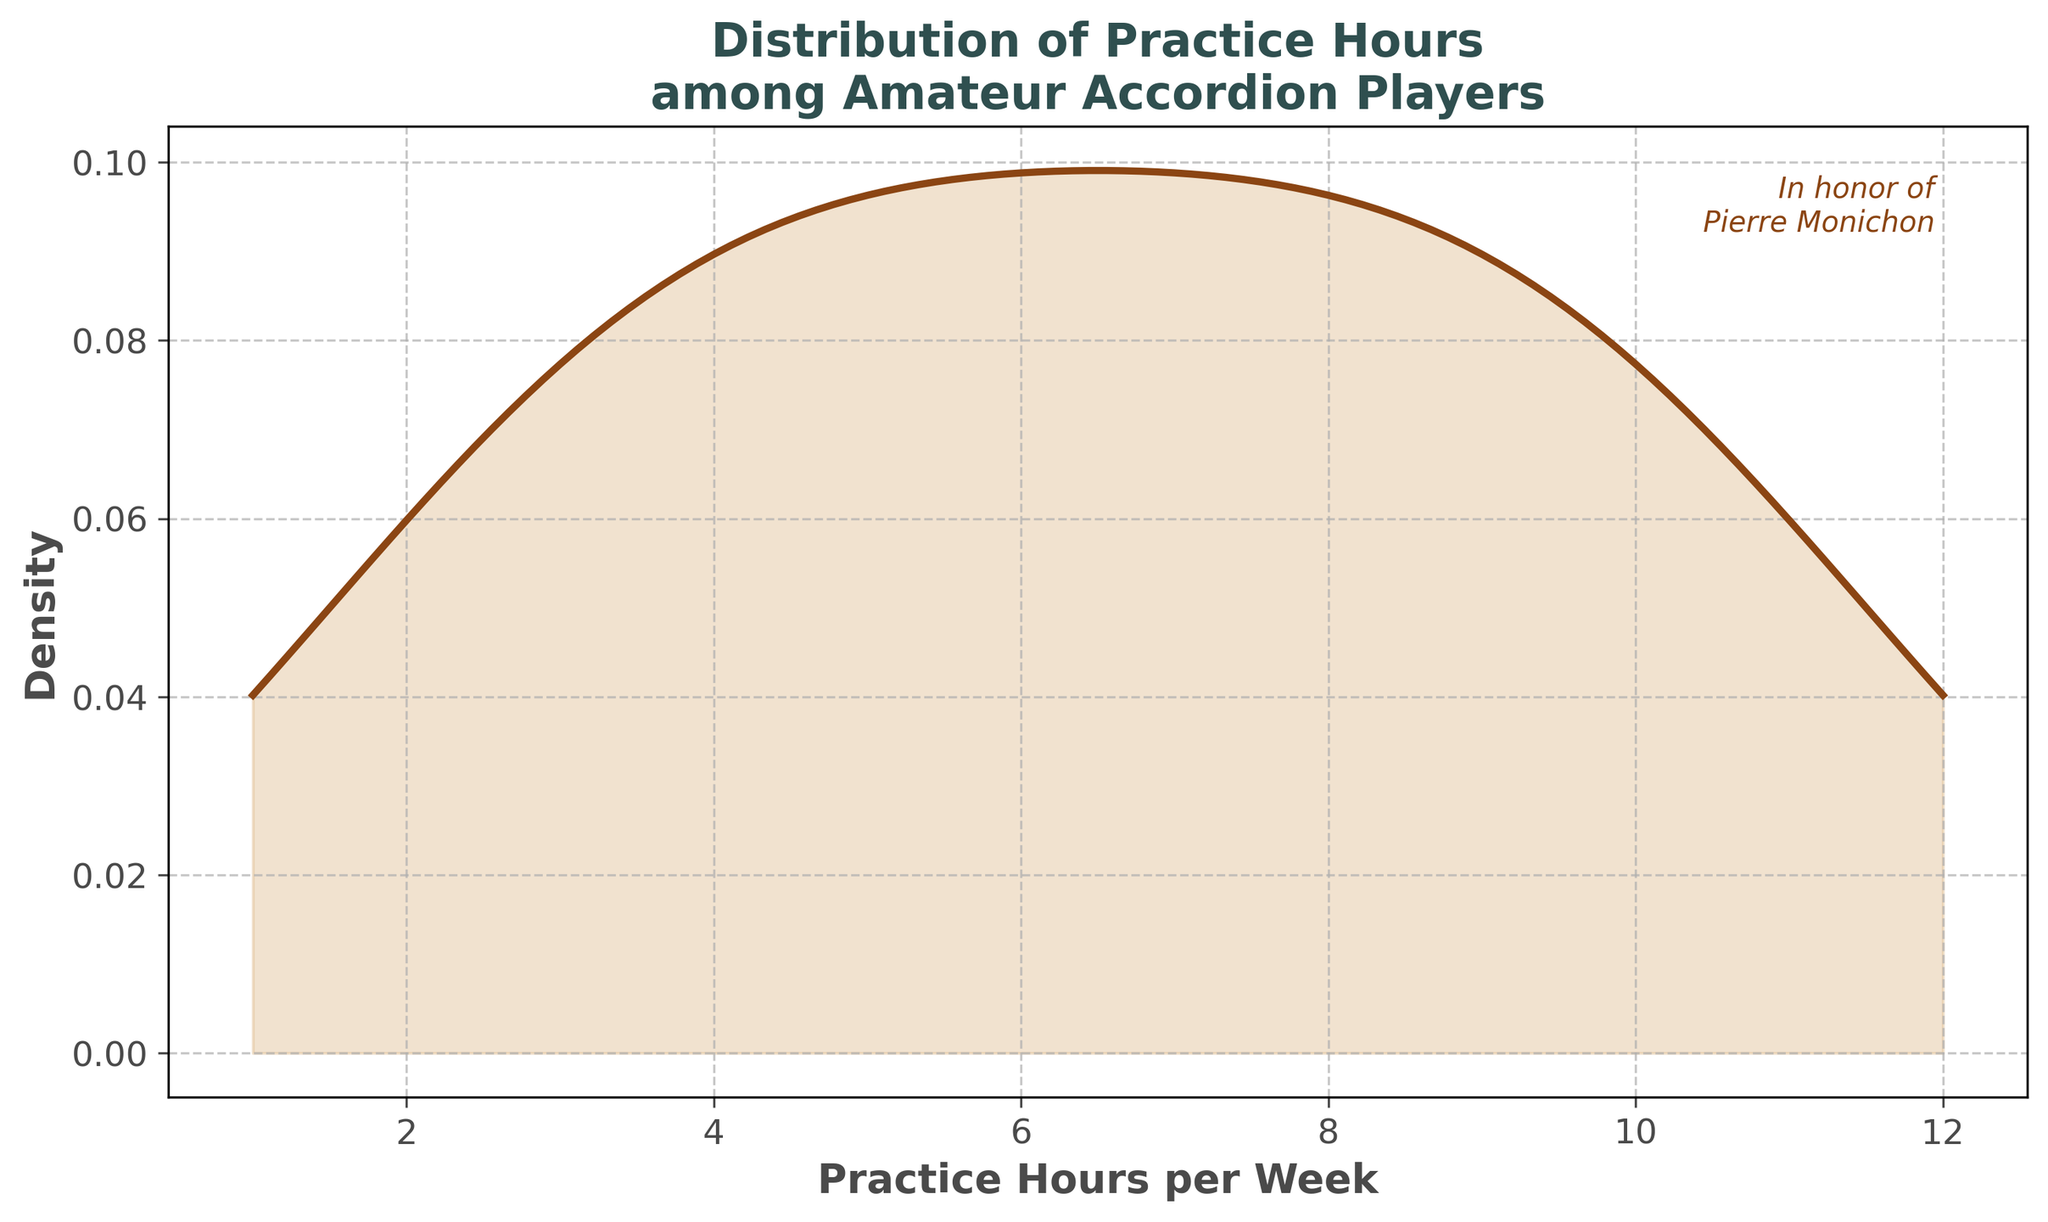What's the title of the plot? The title is displayed at the top of the plot.
Answer: Distribution of Practice Hours among Amateur Accordion Players What range of practice hours does the x-axis cover? To find the range, observe the minimum and maximum values on the x-axis.
Answer: 1 to 12 hours What does the y-axis represent? The label on the y-axis indicates what it measures.
Answer: Density What color is used for the line in the density plot? Observe the appearance and describe the visible color of the plot line.
Answer: Brown Which practice hour value appears to have the highest density? Look for the peak point on the plot where the density reaches its maximum.
Answer: Around 6 hours Does the density plot seem to indicate a single peak or multiple peaks? Analyze the number of distinct high points in the density curve. Single peak indicates a unimodal distribution, multiple peaks indicate a multimodal distribution.
Answer: Single peak What is the approximate density value for 10 practice hours per week? Find the x-value of 10 on the plot and identify the corresponding y-value on the density curve.
Answer: Around 0.08 What message is written in honor of Pierre Monichon? Refer to any specific text annotation in the plot paying homage to Pierre Monichon.
Answer: In honor of Pierre Monichon Compare the density of practice hours between 4 hours and 8 hours. Which is higher? Identify the y-values for the practice hours of interest and compare them.
Answer: 8 hours has a higher density Between practice hours of 5 and 7 per week, which hour shows a higher density? Examine the y-values corresponding to 5 and 7 practice hours to identify which is higher.
Answer: 7 hours 